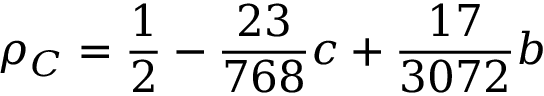Convert formula to latex. <formula><loc_0><loc_0><loc_500><loc_500>\rho _ { C } = \frac { 1 } { 2 } - \frac { 2 3 } { 7 6 8 } c + \frac { 1 7 } { 3 0 7 2 } b</formula> 